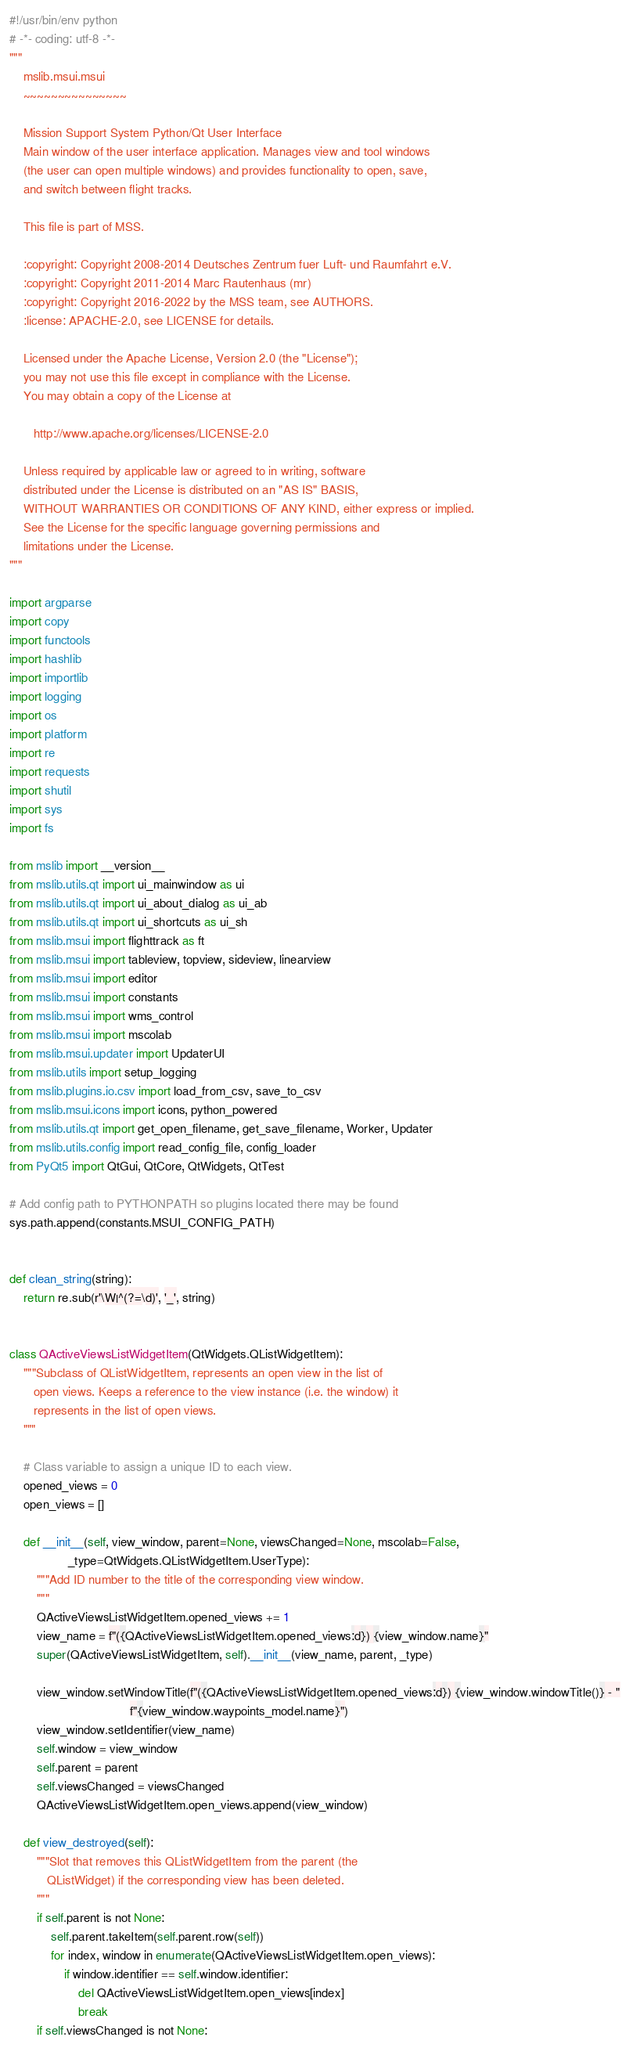<code> <loc_0><loc_0><loc_500><loc_500><_Python_>#!/usr/bin/env python
# -*- coding: utf-8 -*-
"""
    mslib.msui.msui
    ~~~~~~~~~~~~~~~

    Mission Support System Python/Qt User Interface
    Main window of the user interface application. Manages view and tool windows
    (the user can open multiple windows) and provides functionality to open, save,
    and switch between flight tracks.

    This file is part of MSS.

    :copyright: Copyright 2008-2014 Deutsches Zentrum fuer Luft- und Raumfahrt e.V.
    :copyright: Copyright 2011-2014 Marc Rautenhaus (mr)
    :copyright: Copyright 2016-2022 by the MSS team, see AUTHORS.
    :license: APACHE-2.0, see LICENSE for details.

    Licensed under the Apache License, Version 2.0 (the "License");
    you may not use this file except in compliance with the License.
    You may obtain a copy of the License at

       http://www.apache.org/licenses/LICENSE-2.0

    Unless required by applicable law or agreed to in writing, software
    distributed under the License is distributed on an "AS IS" BASIS,
    WITHOUT WARRANTIES OR CONDITIONS OF ANY KIND, either express or implied.
    See the License for the specific language governing permissions and
    limitations under the License.
"""

import argparse
import copy
import functools
import hashlib
import importlib
import logging
import os
import platform
import re
import requests
import shutil
import sys
import fs

from mslib import __version__
from mslib.utils.qt import ui_mainwindow as ui
from mslib.utils.qt import ui_about_dialog as ui_ab
from mslib.utils.qt import ui_shortcuts as ui_sh
from mslib.msui import flighttrack as ft
from mslib.msui import tableview, topview, sideview, linearview
from mslib.msui import editor
from mslib.msui import constants
from mslib.msui import wms_control
from mslib.msui import mscolab
from mslib.msui.updater import UpdaterUI
from mslib.utils import setup_logging
from mslib.plugins.io.csv import load_from_csv, save_to_csv
from mslib.msui.icons import icons, python_powered
from mslib.utils.qt import get_open_filename, get_save_filename, Worker, Updater
from mslib.utils.config import read_config_file, config_loader
from PyQt5 import QtGui, QtCore, QtWidgets, QtTest

# Add config path to PYTHONPATH so plugins located there may be found
sys.path.append(constants.MSUI_CONFIG_PATH)


def clean_string(string):
    return re.sub(r'\W|^(?=\d)', '_', string)


class QActiveViewsListWidgetItem(QtWidgets.QListWidgetItem):
    """Subclass of QListWidgetItem, represents an open view in the list of
       open views. Keeps a reference to the view instance (i.e. the window) it
       represents in the list of open views.
    """

    # Class variable to assign a unique ID to each view.
    opened_views = 0
    open_views = []

    def __init__(self, view_window, parent=None, viewsChanged=None, mscolab=False,
                 _type=QtWidgets.QListWidgetItem.UserType):
        """Add ID number to the title of the corresponding view window.
        """
        QActiveViewsListWidgetItem.opened_views += 1
        view_name = f"({QActiveViewsListWidgetItem.opened_views:d}) {view_window.name}"
        super(QActiveViewsListWidgetItem, self).__init__(view_name, parent, _type)

        view_window.setWindowTitle(f"({QActiveViewsListWidgetItem.opened_views:d}) {view_window.windowTitle()} - "
                                   f"{view_window.waypoints_model.name}")
        view_window.setIdentifier(view_name)
        self.window = view_window
        self.parent = parent
        self.viewsChanged = viewsChanged
        QActiveViewsListWidgetItem.open_views.append(view_window)

    def view_destroyed(self):
        """Slot that removes this QListWidgetItem from the parent (the
           QListWidget) if the corresponding view has been deleted.
        """
        if self.parent is not None:
            self.parent.takeItem(self.parent.row(self))
            for index, window in enumerate(QActiveViewsListWidgetItem.open_views):
                if window.identifier == self.window.identifier:
                    del QActiveViewsListWidgetItem.open_views[index]
                    break
        if self.viewsChanged is not None:</code> 